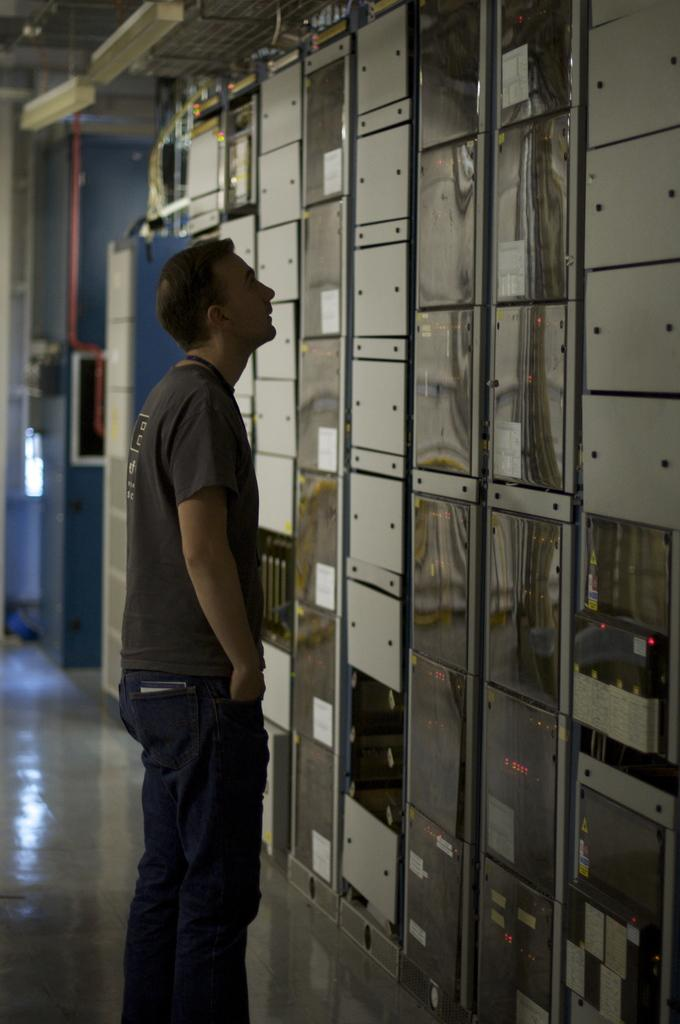What is the main subject of the image? There is a man standing in the image. Can you describe the background of the image? There are machines in the background of the image. What type of jelly can be seen on the man's shoes in the image? There is no jelly visible on the man's shoes in the image. Can you describe the kicking motion of the man in the image? The man is not kicking in the image; he is standing still. 